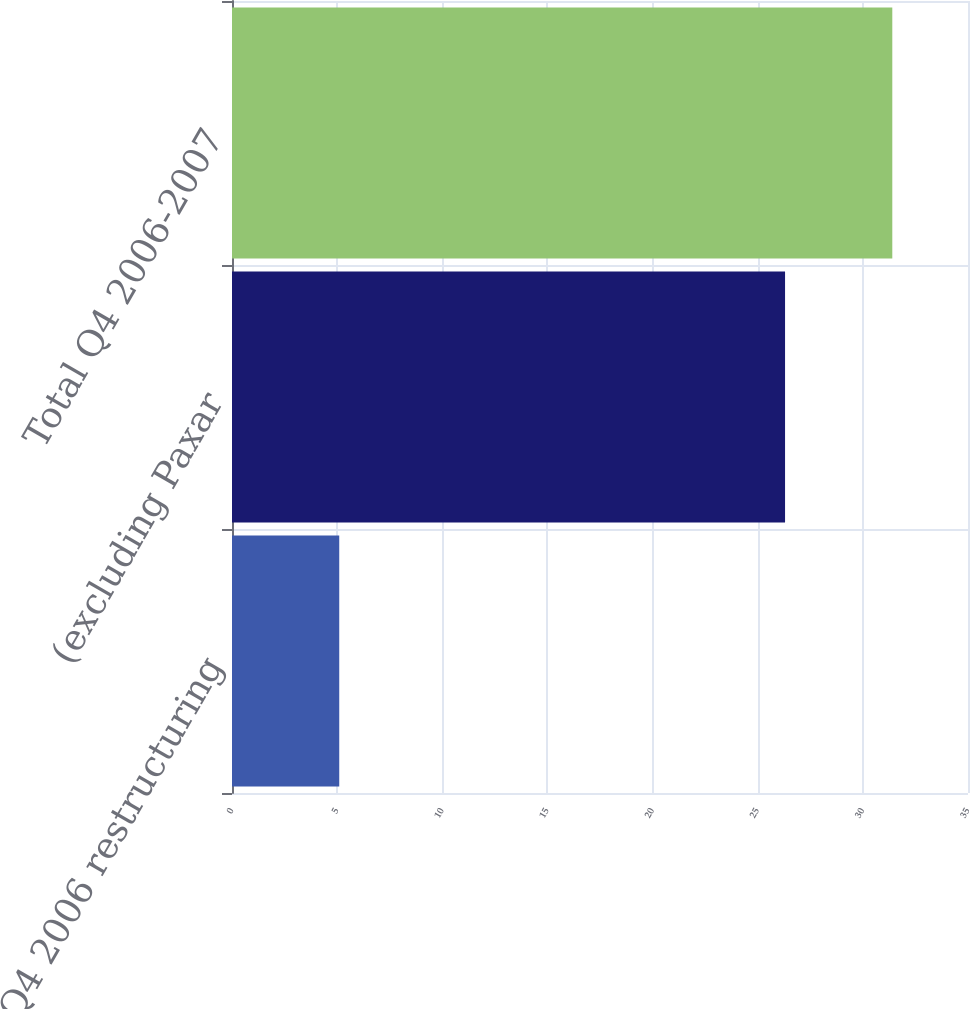Convert chart to OTSL. <chart><loc_0><loc_0><loc_500><loc_500><bar_chart><fcel>Q4 2006 restructuring<fcel>(excluding Paxar<fcel>Total Q4 2006-2007<nl><fcel>5.1<fcel>26.3<fcel>31.4<nl></chart> 